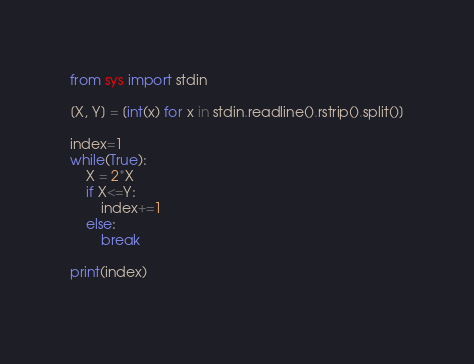Convert code to text. <code><loc_0><loc_0><loc_500><loc_500><_Python_>from sys import stdin

[X, Y] = [int(x) for x in stdin.readline().rstrip().split()]

index=1
while(True):
    X = 2*X
    if X<=Y:
        index+=1
    else:
        break

print(index)
    



</code> 